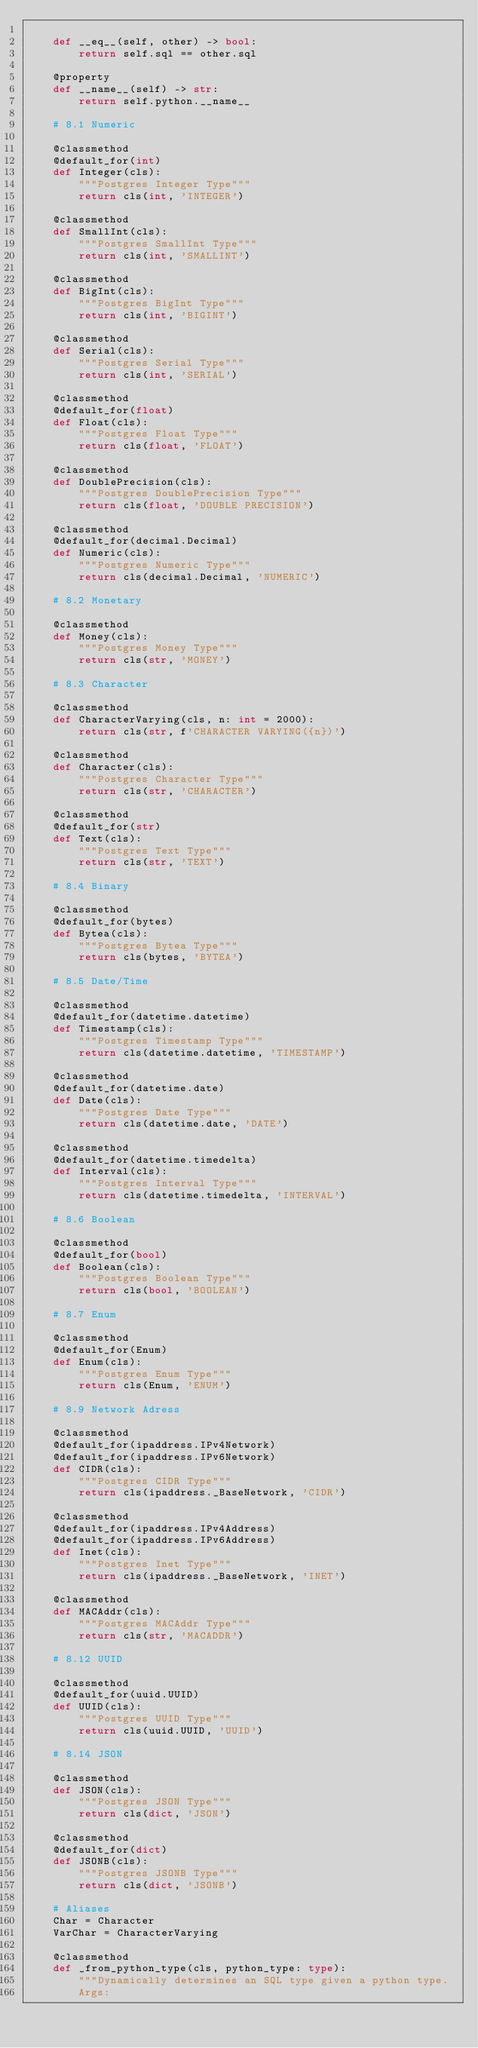<code> <loc_0><loc_0><loc_500><loc_500><_Python_>
    def __eq__(self, other) -> bool:
        return self.sql == other.sql

    @property
    def __name__(self) -> str:
        return self.python.__name__

    # 8.1 Numeric

    @classmethod
    @default_for(int)
    def Integer(cls):
        """Postgres Integer Type"""
        return cls(int, 'INTEGER')

    @classmethod
    def SmallInt(cls):
        """Postgres SmallInt Type"""
        return cls(int, 'SMALLINT')

    @classmethod
    def BigInt(cls):
        """Postgres BigInt Type"""
        return cls(int, 'BIGINT')

    @classmethod
    def Serial(cls):
        """Postgres Serial Type"""
        return cls(int, 'SERIAL')

    @classmethod
    @default_for(float)
    def Float(cls):
        """Postgres Float Type"""
        return cls(float, 'FLOAT')

    @classmethod
    def DoublePrecision(cls):
        """Postgres DoublePrecision Type"""
        return cls(float, 'DOUBLE PRECISION')

    @classmethod
    @default_for(decimal.Decimal)
    def Numeric(cls):
        """Postgres Numeric Type"""
        return cls(decimal.Decimal, 'NUMERIC')

    # 8.2 Monetary

    @classmethod
    def Money(cls):
        """Postgres Money Type"""
        return cls(str, 'MONEY')

    # 8.3 Character

    @classmethod
    def CharacterVarying(cls, n: int = 2000):
        return cls(str, f'CHARACTER VARYING({n})')

    @classmethod
    def Character(cls):
        """Postgres Character Type"""
        return cls(str, 'CHARACTER')

    @classmethod
    @default_for(str)
    def Text(cls):
        """Postgres Text Type"""
        return cls(str, 'TEXT')

    # 8.4 Binary

    @classmethod
    @default_for(bytes)
    def Bytea(cls):
        """Postgres Bytea Type"""
        return cls(bytes, 'BYTEA')

    # 8.5 Date/Time

    @classmethod
    @default_for(datetime.datetime)
    def Timestamp(cls):
        """Postgres Timestamp Type"""
        return cls(datetime.datetime, 'TIMESTAMP')

    @classmethod
    @default_for(datetime.date)
    def Date(cls):
        """Postgres Date Type"""
        return cls(datetime.date, 'DATE')

    @classmethod
    @default_for(datetime.timedelta)
    def Interval(cls):
        """Postgres Interval Type"""
        return cls(datetime.timedelta, 'INTERVAL')

    # 8.6 Boolean

    @classmethod
    @default_for(bool)
    def Boolean(cls):
        """Postgres Boolean Type"""
        return cls(bool, 'BOOLEAN')

    # 8.7 Enum

    @classmethod
    @default_for(Enum)
    def Enum(cls):
        """Postgres Enum Type"""
        return cls(Enum, 'ENUM')

    # 8.9 Network Adress

    @classmethod
    @default_for(ipaddress.IPv4Network)
    @default_for(ipaddress.IPv6Network)
    def CIDR(cls):
        """Postgres CIDR Type"""
        return cls(ipaddress._BaseNetwork, 'CIDR')

    @classmethod
    @default_for(ipaddress.IPv4Address)
    @default_for(ipaddress.IPv6Address)
    def Inet(cls):
        """Postgres Inet Type"""
        return cls(ipaddress._BaseNetwork, 'INET')

    @classmethod
    def MACAddr(cls):
        """Postgres MACAddr Type"""
        return cls(str, 'MACADDR')

    # 8.12 UUID

    @classmethod
    @default_for(uuid.UUID)
    def UUID(cls):
        """Postgres UUID Type"""
        return cls(uuid.UUID, 'UUID')

    # 8.14 JSON

    @classmethod
    def JSON(cls):
        """Postgres JSON Type"""
        return cls(dict, 'JSON')

    @classmethod
    @default_for(dict)
    def JSONB(cls):
        """Postgres JSONB Type"""
        return cls(dict, 'JSONB')

    # Aliases
    Char = Character
    VarChar = CharacterVarying

    @classmethod
    def _from_python_type(cls, python_type: type):
        """Dynamically determines an SQL type given a python type.
        Args:</code> 